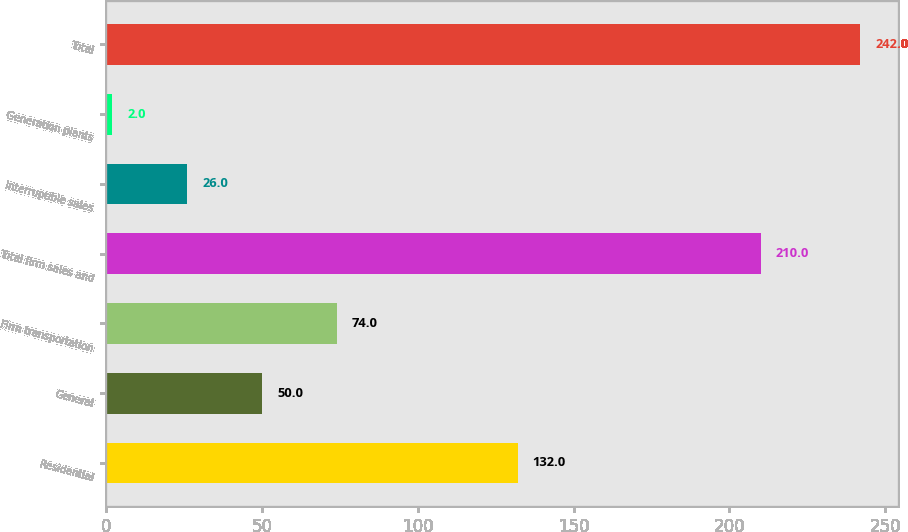Convert chart. <chart><loc_0><loc_0><loc_500><loc_500><bar_chart><fcel>Residential<fcel>General<fcel>Firm transportation<fcel>Total firm sales and<fcel>Interruptible sales<fcel>Generation plants<fcel>Total<nl><fcel>132<fcel>50<fcel>74<fcel>210<fcel>26<fcel>2<fcel>242<nl></chart> 